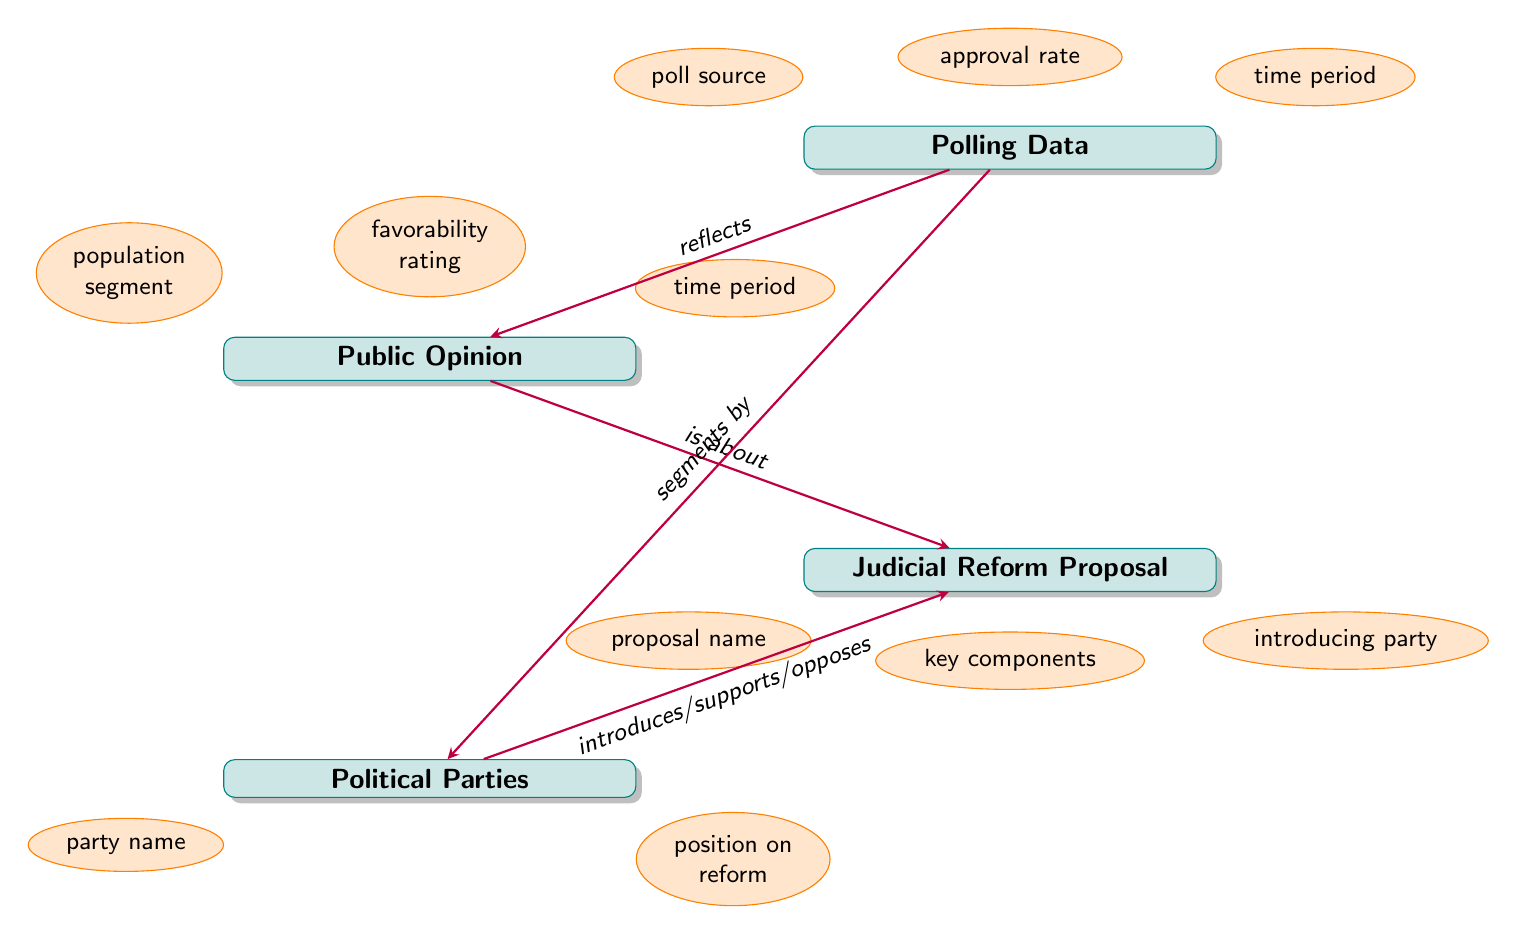What are the attributes of Public Opinion? The diagram indicates that Public Opinion has three attributes: population segment, favorability rating, and time period. These attributes provide insight into what factors characterize public opinion.
Answer: population segment, favorability rating, time period How many entities are present in the diagram? By counting the rectangles representing different entities, we identify four entities: Public Opinion, Judicial Reform Proposal, Polling Data, and Political Parties. Thus, the total number of entities is four.
Answer: 4 What relationship connects Public Opinion to Judicial Reform Proposal? The diagram specifies that the relationship between Public Opinion and Judicial Reform Proposal is described as "is about." This indicates that public opinion is directed toward or concerning the judicial reform proposal.
Answer: is about What attribute does Polling Data share with Public Opinion? Both Public Opinion and Polling Data have a common attribute: time period. This attribute suggests that there is a timeframe within which public opinion and polling data are measured.
Answer: time period How do Political Parties relate to Judicial Reform Proposal? The diagram illustrates that Political Parties interact with Judicial Reform Proposal through the relationship described as "introduces/supports/opposes". This indicates that political parties may play various roles regarding these proposals.
Answer: introduces/supports/opposes What does Polling Data reflect? According to the diagram, Polling Data reflects Public Opinion. This means that the polling data gives a snapshot of public sentiment regarding an issue or reform.
Answer: Public Opinion Which entity is segmented by Polling Data? The diagram shows that Polling Data segments Political Parties. This suggests that polling data distinguishes or categorizes how different political parties align with public opinion on judicial reform.
Answer: Political Parties How many attributes does Judicial Reform Proposal have? The diagram identifies three attributes associated with Judicial Reform Proposal: proposal name, key components, and introducing party. Counting these attributes indicates that there are three.
Answer: 3 What is the relationship between Polling Data and Political Parties? The relationship between Polling Data and Political Parties is indicated as "segments by". This indicates that polling data provides a division or analysis of positions held by different political parties regarding judicial reform.
Answer: segments by 